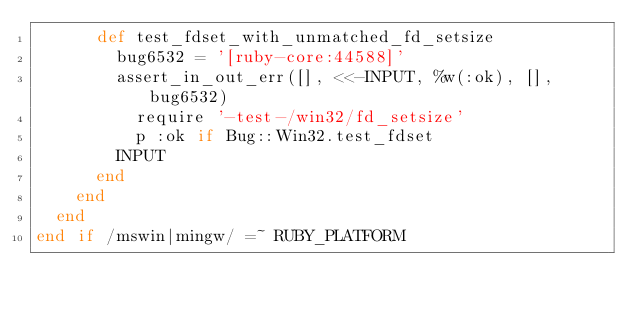Convert code to text. <code><loc_0><loc_0><loc_500><loc_500><_Ruby_>      def test_fdset_with_unmatched_fd_setsize
        bug6532 = '[ruby-core:44588]'
        assert_in_out_err([], <<-INPUT, %w(:ok), [], bug6532)
          require '-test-/win32/fd_setsize'
          p :ok if Bug::Win32.test_fdset
        INPUT
      end
    end
  end
end if /mswin|mingw/ =~ RUBY_PLATFORM
</code> 